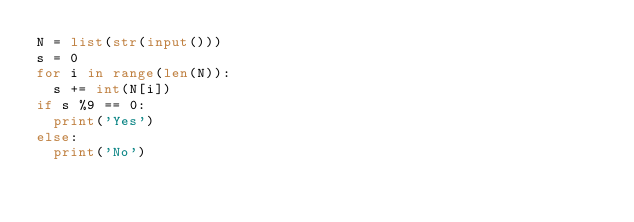<code> <loc_0><loc_0><loc_500><loc_500><_Python_>N = list(str(input()))
s = 0
for i in range(len(N)):
  s += int(N[i])
if s %9 == 0:
  print('Yes')
else:
  print('No')
</code> 